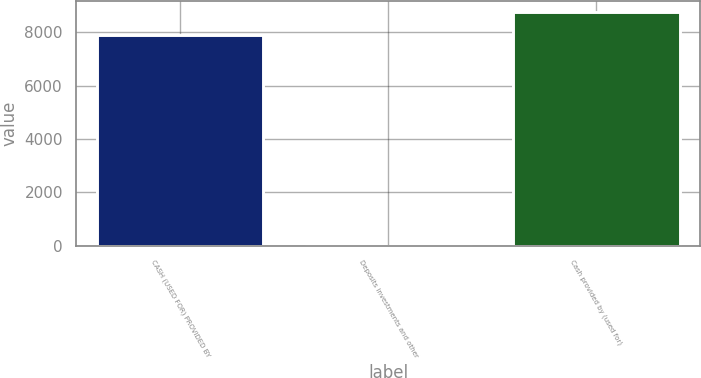Convert chart to OTSL. <chart><loc_0><loc_0><loc_500><loc_500><bar_chart><fcel>CASH (USED FOR) PROVIDED BY<fcel>Deposits investments and other<fcel>Cash provided by (used for)<nl><fcel>7897<fcel>2<fcel>8743.3<nl></chart> 